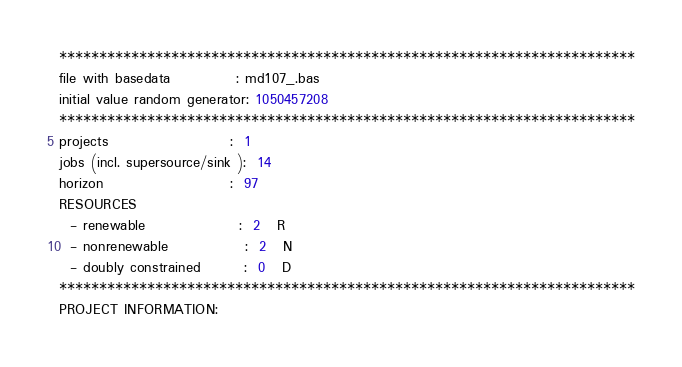<code> <loc_0><loc_0><loc_500><loc_500><_ObjectiveC_>************************************************************************
file with basedata            : md107_.bas
initial value random generator: 1050457208
************************************************************************
projects                      :  1
jobs (incl. supersource/sink ):  14
horizon                       :  97
RESOURCES
  - renewable                 :  2   R
  - nonrenewable              :  2   N
  - doubly constrained        :  0   D
************************************************************************
PROJECT INFORMATION:</code> 